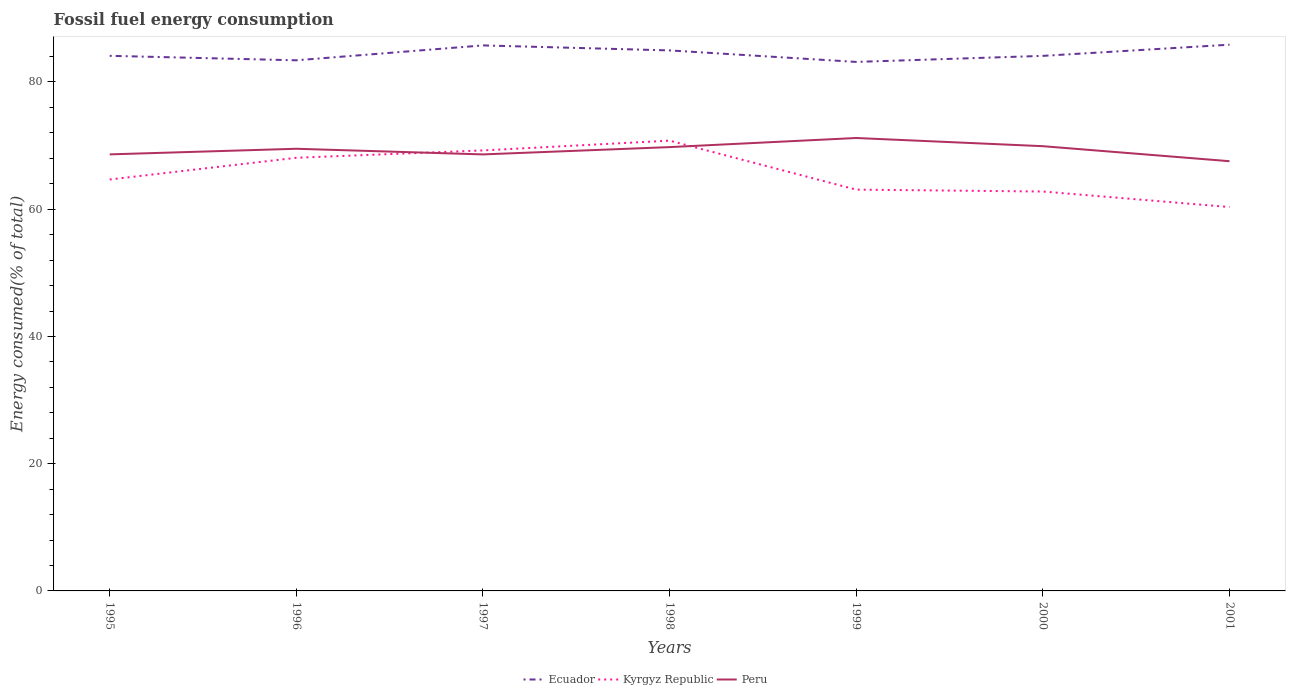How many different coloured lines are there?
Give a very brief answer. 3. Does the line corresponding to Peru intersect with the line corresponding to Kyrgyz Republic?
Your answer should be compact. Yes. Is the number of lines equal to the number of legend labels?
Offer a very short reply. Yes. Across all years, what is the maximum percentage of energy consumed in Kyrgyz Republic?
Provide a short and direct response. 60.34. In which year was the percentage of energy consumed in Ecuador maximum?
Your response must be concise. 1999. What is the total percentage of energy consumed in Kyrgyz Republic in the graph?
Provide a short and direct response. 6.16. What is the difference between the highest and the second highest percentage of energy consumed in Kyrgyz Republic?
Your response must be concise. 10.44. What is the difference between the highest and the lowest percentage of energy consumed in Ecuador?
Provide a succinct answer. 3. Is the percentage of energy consumed in Kyrgyz Republic strictly greater than the percentage of energy consumed in Peru over the years?
Your answer should be compact. No. How many years are there in the graph?
Provide a succinct answer. 7. What is the difference between two consecutive major ticks on the Y-axis?
Offer a very short reply. 20. Does the graph contain any zero values?
Keep it short and to the point. No. Where does the legend appear in the graph?
Your response must be concise. Bottom center. How many legend labels are there?
Give a very brief answer. 3. What is the title of the graph?
Offer a terse response. Fossil fuel energy consumption. Does "Nepal" appear as one of the legend labels in the graph?
Your answer should be compact. No. What is the label or title of the Y-axis?
Your response must be concise. Energy consumed(% of total). What is the Energy consumed(% of total) of Ecuador in 1995?
Your response must be concise. 84.11. What is the Energy consumed(% of total) of Kyrgyz Republic in 1995?
Offer a terse response. 64.67. What is the Energy consumed(% of total) of Peru in 1995?
Keep it short and to the point. 68.62. What is the Energy consumed(% of total) in Ecuador in 1996?
Give a very brief answer. 83.41. What is the Energy consumed(% of total) of Kyrgyz Republic in 1996?
Your answer should be compact. 68.09. What is the Energy consumed(% of total) in Peru in 1996?
Your answer should be compact. 69.5. What is the Energy consumed(% of total) in Ecuador in 1997?
Your answer should be compact. 85.75. What is the Energy consumed(% of total) in Kyrgyz Republic in 1997?
Your answer should be compact. 69.25. What is the Energy consumed(% of total) in Peru in 1997?
Provide a succinct answer. 68.62. What is the Energy consumed(% of total) of Ecuador in 1998?
Give a very brief answer. 84.97. What is the Energy consumed(% of total) in Kyrgyz Republic in 1998?
Offer a terse response. 70.78. What is the Energy consumed(% of total) of Peru in 1998?
Make the answer very short. 69.77. What is the Energy consumed(% of total) in Ecuador in 1999?
Provide a succinct answer. 83.16. What is the Energy consumed(% of total) of Kyrgyz Republic in 1999?
Keep it short and to the point. 63.08. What is the Energy consumed(% of total) in Peru in 1999?
Your response must be concise. 71.2. What is the Energy consumed(% of total) of Ecuador in 2000?
Your answer should be very brief. 84.11. What is the Energy consumed(% of total) in Kyrgyz Republic in 2000?
Provide a short and direct response. 62.78. What is the Energy consumed(% of total) in Peru in 2000?
Provide a succinct answer. 69.91. What is the Energy consumed(% of total) in Ecuador in 2001?
Make the answer very short. 85.86. What is the Energy consumed(% of total) in Kyrgyz Republic in 2001?
Your response must be concise. 60.34. What is the Energy consumed(% of total) of Peru in 2001?
Make the answer very short. 67.55. Across all years, what is the maximum Energy consumed(% of total) in Ecuador?
Ensure brevity in your answer.  85.86. Across all years, what is the maximum Energy consumed(% of total) in Kyrgyz Republic?
Ensure brevity in your answer.  70.78. Across all years, what is the maximum Energy consumed(% of total) of Peru?
Your answer should be compact. 71.2. Across all years, what is the minimum Energy consumed(% of total) in Ecuador?
Your answer should be very brief. 83.16. Across all years, what is the minimum Energy consumed(% of total) of Kyrgyz Republic?
Your answer should be compact. 60.34. Across all years, what is the minimum Energy consumed(% of total) in Peru?
Your answer should be very brief. 67.55. What is the total Energy consumed(% of total) of Ecuador in the graph?
Provide a succinct answer. 591.37. What is the total Energy consumed(% of total) in Kyrgyz Republic in the graph?
Your response must be concise. 459. What is the total Energy consumed(% of total) of Peru in the graph?
Provide a short and direct response. 485.17. What is the difference between the Energy consumed(% of total) of Ecuador in 1995 and that in 1996?
Make the answer very short. 0.7. What is the difference between the Energy consumed(% of total) of Kyrgyz Republic in 1995 and that in 1996?
Keep it short and to the point. -3.42. What is the difference between the Energy consumed(% of total) in Peru in 1995 and that in 1996?
Give a very brief answer. -0.88. What is the difference between the Energy consumed(% of total) in Ecuador in 1995 and that in 1997?
Offer a very short reply. -1.64. What is the difference between the Energy consumed(% of total) in Kyrgyz Republic in 1995 and that in 1997?
Your response must be concise. -4.57. What is the difference between the Energy consumed(% of total) of Peru in 1995 and that in 1997?
Your response must be concise. 0.01. What is the difference between the Energy consumed(% of total) of Ecuador in 1995 and that in 1998?
Make the answer very short. -0.85. What is the difference between the Energy consumed(% of total) of Kyrgyz Republic in 1995 and that in 1998?
Your response must be concise. -6.11. What is the difference between the Energy consumed(% of total) in Peru in 1995 and that in 1998?
Offer a very short reply. -1.14. What is the difference between the Energy consumed(% of total) of Ecuador in 1995 and that in 1999?
Your answer should be very brief. 0.96. What is the difference between the Energy consumed(% of total) in Kyrgyz Republic in 1995 and that in 1999?
Provide a short and direct response. 1.59. What is the difference between the Energy consumed(% of total) in Peru in 1995 and that in 1999?
Offer a very short reply. -2.57. What is the difference between the Energy consumed(% of total) of Ecuador in 1995 and that in 2000?
Give a very brief answer. 0.01. What is the difference between the Energy consumed(% of total) of Kyrgyz Republic in 1995 and that in 2000?
Keep it short and to the point. 1.89. What is the difference between the Energy consumed(% of total) of Peru in 1995 and that in 2000?
Ensure brevity in your answer.  -1.29. What is the difference between the Energy consumed(% of total) of Ecuador in 1995 and that in 2001?
Your answer should be compact. -1.75. What is the difference between the Energy consumed(% of total) in Kyrgyz Republic in 1995 and that in 2001?
Your answer should be very brief. 4.33. What is the difference between the Energy consumed(% of total) of Peru in 1995 and that in 2001?
Offer a terse response. 1.07. What is the difference between the Energy consumed(% of total) in Ecuador in 1996 and that in 1997?
Ensure brevity in your answer.  -2.34. What is the difference between the Energy consumed(% of total) in Kyrgyz Republic in 1996 and that in 1997?
Provide a succinct answer. -1.16. What is the difference between the Energy consumed(% of total) in Peru in 1996 and that in 1997?
Give a very brief answer. 0.89. What is the difference between the Energy consumed(% of total) of Ecuador in 1996 and that in 1998?
Offer a terse response. -1.55. What is the difference between the Energy consumed(% of total) of Kyrgyz Republic in 1996 and that in 1998?
Give a very brief answer. -2.69. What is the difference between the Energy consumed(% of total) in Peru in 1996 and that in 1998?
Make the answer very short. -0.26. What is the difference between the Energy consumed(% of total) in Ecuador in 1996 and that in 1999?
Give a very brief answer. 0.25. What is the difference between the Energy consumed(% of total) of Kyrgyz Republic in 1996 and that in 1999?
Provide a short and direct response. 5.01. What is the difference between the Energy consumed(% of total) in Peru in 1996 and that in 1999?
Make the answer very short. -1.69. What is the difference between the Energy consumed(% of total) in Ecuador in 1996 and that in 2000?
Your answer should be very brief. -0.7. What is the difference between the Energy consumed(% of total) of Kyrgyz Republic in 1996 and that in 2000?
Provide a short and direct response. 5.31. What is the difference between the Energy consumed(% of total) of Peru in 1996 and that in 2000?
Keep it short and to the point. -0.4. What is the difference between the Energy consumed(% of total) in Ecuador in 1996 and that in 2001?
Provide a succinct answer. -2.45. What is the difference between the Energy consumed(% of total) in Kyrgyz Republic in 1996 and that in 2001?
Make the answer very short. 7.75. What is the difference between the Energy consumed(% of total) in Peru in 1996 and that in 2001?
Provide a succinct answer. 1.96. What is the difference between the Energy consumed(% of total) of Ecuador in 1997 and that in 1998?
Keep it short and to the point. 0.79. What is the difference between the Energy consumed(% of total) of Kyrgyz Republic in 1997 and that in 1998?
Give a very brief answer. -1.53. What is the difference between the Energy consumed(% of total) in Peru in 1997 and that in 1998?
Offer a terse response. -1.15. What is the difference between the Energy consumed(% of total) of Ecuador in 1997 and that in 1999?
Offer a very short reply. 2.59. What is the difference between the Energy consumed(% of total) in Kyrgyz Republic in 1997 and that in 1999?
Keep it short and to the point. 6.17. What is the difference between the Energy consumed(% of total) in Peru in 1997 and that in 1999?
Ensure brevity in your answer.  -2.58. What is the difference between the Energy consumed(% of total) of Ecuador in 1997 and that in 2000?
Offer a very short reply. 1.64. What is the difference between the Energy consumed(% of total) of Kyrgyz Republic in 1997 and that in 2000?
Give a very brief answer. 6.46. What is the difference between the Energy consumed(% of total) in Peru in 1997 and that in 2000?
Give a very brief answer. -1.29. What is the difference between the Energy consumed(% of total) of Ecuador in 1997 and that in 2001?
Keep it short and to the point. -0.11. What is the difference between the Energy consumed(% of total) of Kyrgyz Republic in 1997 and that in 2001?
Provide a short and direct response. 8.9. What is the difference between the Energy consumed(% of total) in Peru in 1997 and that in 2001?
Provide a short and direct response. 1.07. What is the difference between the Energy consumed(% of total) of Ecuador in 1998 and that in 1999?
Provide a short and direct response. 1.81. What is the difference between the Energy consumed(% of total) of Kyrgyz Republic in 1998 and that in 1999?
Ensure brevity in your answer.  7.7. What is the difference between the Energy consumed(% of total) of Peru in 1998 and that in 1999?
Offer a very short reply. -1.43. What is the difference between the Energy consumed(% of total) of Ecuador in 1998 and that in 2000?
Your answer should be compact. 0.86. What is the difference between the Energy consumed(% of total) in Kyrgyz Republic in 1998 and that in 2000?
Make the answer very short. 8. What is the difference between the Energy consumed(% of total) in Peru in 1998 and that in 2000?
Make the answer very short. -0.14. What is the difference between the Energy consumed(% of total) of Ecuador in 1998 and that in 2001?
Provide a short and direct response. -0.9. What is the difference between the Energy consumed(% of total) of Kyrgyz Republic in 1998 and that in 2001?
Give a very brief answer. 10.44. What is the difference between the Energy consumed(% of total) in Peru in 1998 and that in 2001?
Your response must be concise. 2.22. What is the difference between the Energy consumed(% of total) of Ecuador in 1999 and that in 2000?
Offer a terse response. -0.95. What is the difference between the Energy consumed(% of total) of Kyrgyz Republic in 1999 and that in 2000?
Provide a short and direct response. 0.3. What is the difference between the Energy consumed(% of total) of Peru in 1999 and that in 2000?
Provide a succinct answer. 1.29. What is the difference between the Energy consumed(% of total) in Ecuador in 1999 and that in 2001?
Offer a very short reply. -2.71. What is the difference between the Energy consumed(% of total) in Kyrgyz Republic in 1999 and that in 2001?
Offer a terse response. 2.74. What is the difference between the Energy consumed(% of total) in Peru in 1999 and that in 2001?
Give a very brief answer. 3.65. What is the difference between the Energy consumed(% of total) of Ecuador in 2000 and that in 2001?
Provide a short and direct response. -1.76. What is the difference between the Energy consumed(% of total) in Kyrgyz Republic in 2000 and that in 2001?
Your answer should be very brief. 2.44. What is the difference between the Energy consumed(% of total) of Peru in 2000 and that in 2001?
Offer a terse response. 2.36. What is the difference between the Energy consumed(% of total) of Ecuador in 1995 and the Energy consumed(% of total) of Kyrgyz Republic in 1996?
Your response must be concise. 16.03. What is the difference between the Energy consumed(% of total) in Ecuador in 1995 and the Energy consumed(% of total) in Peru in 1996?
Provide a succinct answer. 14.61. What is the difference between the Energy consumed(% of total) in Kyrgyz Republic in 1995 and the Energy consumed(% of total) in Peru in 1996?
Make the answer very short. -4.83. What is the difference between the Energy consumed(% of total) of Ecuador in 1995 and the Energy consumed(% of total) of Kyrgyz Republic in 1997?
Your answer should be very brief. 14.87. What is the difference between the Energy consumed(% of total) of Ecuador in 1995 and the Energy consumed(% of total) of Peru in 1997?
Offer a very short reply. 15.5. What is the difference between the Energy consumed(% of total) in Kyrgyz Republic in 1995 and the Energy consumed(% of total) in Peru in 1997?
Provide a succinct answer. -3.94. What is the difference between the Energy consumed(% of total) in Ecuador in 1995 and the Energy consumed(% of total) in Kyrgyz Republic in 1998?
Offer a very short reply. 13.34. What is the difference between the Energy consumed(% of total) in Ecuador in 1995 and the Energy consumed(% of total) in Peru in 1998?
Provide a succinct answer. 14.35. What is the difference between the Energy consumed(% of total) in Kyrgyz Republic in 1995 and the Energy consumed(% of total) in Peru in 1998?
Your answer should be compact. -5.09. What is the difference between the Energy consumed(% of total) of Ecuador in 1995 and the Energy consumed(% of total) of Kyrgyz Republic in 1999?
Keep it short and to the point. 21.03. What is the difference between the Energy consumed(% of total) in Ecuador in 1995 and the Energy consumed(% of total) in Peru in 1999?
Ensure brevity in your answer.  12.92. What is the difference between the Energy consumed(% of total) in Kyrgyz Republic in 1995 and the Energy consumed(% of total) in Peru in 1999?
Give a very brief answer. -6.52. What is the difference between the Energy consumed(% of total) of Ecuador in 1995 and the Energy consumed(% of total) of Kyrgyz Republic in 2000?
Your answer should be very brief. 21.33. What is the difference between the Energy consumed(% of total) of Ecuador in 1995 and the Energy consumed(% of total) of Peru in 2000?
Keep it short and to the point. 14.21. What is the difference between the Energy consumed(% of total) of Kyrgyz Republic in 1995 and the Energy consumed(% of total) of Peru in 2000?
Your response must be concise. -5.24. What is the difference between the Energy consumed(% of total) of Ecuador in 1995 and the Energy consumed(% of total) of Kyrgyz Republic in 2001?
Your answer should be very brief. 23.77. What is the difference between the Energy consumed(% of total) in Ecuador in 1995 and the Energy consumed(% of total) in Peru in 2001?
Give a very brief answer. 16.57. What is the difference between the Energy consumed(% of total) of Kyrgyz Republic in 1995 and the Energy consumed(% of total) of Peru in 2001?
Keep it short and to the point. -2.87. What is the difference between the Energy consumed(% of total) in Ecuador in 1996 and the Energy consumed(% of total) in Kyrgyz Republic in 1997?
Give a very brief answer. 14.16. What is the difference between the Energy consumed(% of total) in Ecuador in 1996 and the Energy consumed(% of total) in Peru in 1997?
Keep it short and to the point. 14.79. What is the difference between the Energy consumed(% of total) in Kyrgyz Republic in 1996 and the Energy consumed(% of total) in Peru in 1997?
Keep it short and to the point. -0.53. What is the difference between the Energy consumed(% of total) in Ecuador in 1996 and the Energy consumed(% of total) in Kyrgyz Republic in 1998?
Your response must be concise. 12.63. What is the difference between the Energy consumed(% of total) of Ecuador in 1996 and the Energy consumed(% of total) of Peru in 1998?
Provide a short and direct response. 13.64. What is the difference between the Energy consumed(% of total) in Kyrgyz Republic in 1996 and the Energy consumed(% of total) in Peru in 1998?
Your response must be concise. -1.68. What is the difference between the Energy consumed(% of total) of Ecuador in 1996 and the Energy consumed(% of total) of Kyrgyz Republic in 1999?
Give a very brief answer. 20.33. What is the difference between the Energy consumed(% of total) in Ecuador in 1996 and the Energy consumed(% of total) in Peru in 1999?
Offer a very short reply. 12.21. What is the difference between the Energy consumed(% of total) of Kyrgyz Republic in 1996 and the Energy consumed(% of total) of Peru in 1999?
Offer a very short reply. -3.11. What is the difference between the Energy consumed(% of total) in Ecuador in 1996 and the Energy consumed(% of total) in Kyrgyz Republic in 2000?
Provide a short and direct response. 20.63. What is the difference between the Energy consumed(% of total) in Ecuador in 1996 and the Energy consumed(% of total) in Peru in 2000?
Your response must be concise. 13.5. What is the difference between the Energy consumed(% of total) in Kyrgyz Republic in 1996 and the Energy consumed(% of total) in Peru in 2000?
Offer a terse response. -1.82. What is the difference between the Energy consumed(% of total) of Ecuador in 1996 and the Energy consumed(% of total) of Kyrgyz Republic in 2001?
Make the answer very short. 23.07. What is the difference between the Energy consumed(% of total) of Ecuador in 1996 and the Energy consumed(% of total) of Peru in 2001?
Keep it short and to the point. 15.86. What is the difference between the Energy consumed(% of total) of Kyrgyz Republic in 1996 and the Energy consumed(% of total) of Peru in 2001?
Ensure brevity in your answer.  0.54. What is the difference between the Energy consumed(% of total) of Ecuador in 1997 and the Energy consumed(% of total) of Kyrgyz Republic in 1998?
Your response must be concise. 14.97. What is the difference between the Energy consumed(% of total) of Ecuador in 1997 and the Energy consumed(% of total) of Peru in 1998?
Give a very brief answer. 15.99. What is the difference between the Energy consumed(% of total) of Kyrgyz Republic in 1997 and the Energy consumed(% of total) of Peru in 1998?
Give a very brief answer. -0.52. What is the difference between the Energy consumed(% of total) of Ecuador in 1997 and the Energy consumed(% of total) of Kyrgyz Republic in 1999?
Offer a terse response. 22.67. What is the difference between the Energy consumed(% of total) in Ecuador in 1997 and the Energy consumed(% of total) in Peru in 1999?
Provide a succinct answer. 14.55. What is the difference between the Energy consumed(% of total) of Kyrgyz Republic in 1997 and the Energy consumed(% of total) of Peru in 1999?
Provide a succinct answer. -1.95. What is the difference between the Energy consumed(% of total) of Ecuador in 1997 and the Energy consumed(% of total) of Kyrgyz Republic in 2000?
Ensure brevity in your answer.  22.97. What is the difference between the Energy consumed(% of total) of Ecuador in 1997 and the Energy consumed(% of total) of Peru in 2000?
Provide a succinct answer. 15.84. What is the difference between the Energy consumed(% of total) of Kyrgyz Republic in 1997 and the Energy consumed(% of total) of Peru in 2000?
Provide a short and direct response. -0.66. What is the difference between the Energy consumed(% of total) in Ecuador in 1997 and the Energy consumed(% of total) in Kyrgyz Republic in 2001?
Provide a short and direct response. 25.41. What is the difference between the Energy consumed(% of total) in Ecuador in 1997 and the Energy consumed(% of total) in Peru in 2001?
Give a very brief answer. 18.2. What is the difference between the Energy consumed(% of total) in Kyrgyz Republic in 1997 and the Energy consumed(% of total) in Peru in 2001?
Offer a very short reply. 1.7. What is the difference between the Energy consumed(% of total) in Ecuador in 1998 and the Energy consumed(% of total) in Kyrgyz Republic in 1999?
Ensure brevity in your answer.  21.88. What is the difference between the Energy consumed(% of total) of Ecuador in 1998 and the Energy consumed(% of total) of Peru in 1999?
Provide a succinct answer. 13.77. What is the difference between the Energy consumed(% of total) in Kyrgyz Republic in 1998 and the Energy consumed(% of total) in Peru in 1999?
Provide a succinct answer. -0.42. What is the difference between the Energy consumed(% of total) of Ecuador in 1998 and the Energy consumed(% of total) of Kyrgyz Republic in 2000?
Your answer should be compact. 22.18. What is the difference between the Energy consumed(% of total) of Ecuador in 1998 and the Energy consumed(% of total) of Peru in 2000?
Offer a terse response. 15.06. What is the difference between the Energy consumed(% of total) of Kyrgyz Republic in 1998 and the Energy consumed(% of total) of Peru in 2000?
Provide a short and direct response. 0.87. What is the difference between the Energy consumed(% of total) in Ecuador in 1998 and the Energy consumed(% of total) in Kyrgyz Republic in 2001?
Ensure brevity in your answer.  24.62. What is the difference between the Energy consumed(% of total) of Ecuador in 1998 and the Energy consumed(% of total) of Peru in 2001?
Ensure brevity in your answer.  17.42. What is the difference between the Energy consumed(% of total) of Kyrgyz Republic in 1998 and the Energy consumed(% of total) of Peru in 2001?
Provide a succinct answer. 3.23. What is the difference between the Energy consumed(% of total) in Ecuador in 1999 and the Energy consumed(% of total) in Kyrgyz Republic in 2000?
Offer a terse response. 20.37. What is the difference between the Energy consumed(% of total) of Ecuador in 1999 and the Energy consumed(% of total) of Peru in 2000?
Your answer should be very brief. 13.25. What is the difference between the Energy consumed(% of total) of Kyrgyz Republic in 1999 and the Energy consumed(% of total) of Peru in 2000?
Provide a short and direct response. -6.83. What is the difference between the Energy consumed(% of total) in Ecuador in 1999 and the Energy consumed(% of total) in Kyrgyz Republic in 2001?
Your response must be concise. 22.81. What is the difference between the Energy consumed(% of total) in Ecuador in 1999 and the Energy consumed(% of total) in Peru in 2001?
Your response must be concise. 15.61. What is the difference between the Energy consumed(% of total) of Kyrgyz Republic in 1999 and the Energy consumed(% of total) of Peru in 2001?
Provide a succinct answer. -4.47. What is the difference between the Energy consumed(% of total) of Ecuador in 2000 and the Energy consumed(% of total) of Kyrgyz Republic in 2001?
Make the answer very short. 23.77. What is the difference between the Energy consumed(% of total) of Ecuador in 2000 and the Energy consumed(% of total) of Peru in 2001?
Your answer should be very brief. 16.56. What is the difference between the Energy consumed(% of total) in Kyrgyz Republic in 2000 and the Energy consumed(% of total) in Peru in 2001?
Your response must be concise. -4.77. What is the average Energy consumed(% of total) of Ecuador per year?
Ensure brevity in your answer.  84.48. What is the average Energy consumed(% of total) of Kyrgyz Republic per year?
Your response must be concise. 65.57. What is the average Energy consumed(% of total) in Peru per year?
Keep it short and to the point. 69.31. In the year 1995, what is the difference between the Energy consumed(% of total) of Ecuador and Energy consumed(% of total) of Kyrgyz Republic?
Provide a short and direct response. 19.44. In the year 1995, what is the difference between the Energy consumed(% of total) in Ecuador and Energy consumed(% of total) in Peru?
Your answer should be very brief. 15.49. In the year 1995, what is the difference between the Energy consumed(% of total) of Kyrgyz Republic and Energy consumed(% of total) of Peru?
Provide a short and direct response. -3.95. In the year 1996, what is the difference between the Energy consumed(% of total) in Ecuador and Energy consumed(% of total) in Kyrgyz Republic?
Provide a short and direct response. 15.32. In the year 1996, what is the difference between the Energy consumed(% of total) in Ecuador and Energy consumed(% of total) in Peru?
Keep it short and to the point. 13.91. In the year 1996, what is the difference between the Energy consumed(% of total) in Kyrgyz Republic and Energy consumed(% of total) in Peru?
Your response must be concise. -1.41. In the year 1997, what is the difference between the Energy consumed(% of total) in Ecuador and Energy consumed(% of total) in Kyrgyz Republic?
Provide a succinct answer. 16.51. In the year 1997, what is the difference between the Energy consumed(% of total) in Ecuador and Energy consumed(% of total) in Peru?
Your answer should be compact. 17.13. In the year 1997, what is the difference between the Energy consumed(% of total) of Kyrgyz Republic and Energy consumed(% of total) of Peru?
Your response must be concise. 0.63. In the year 1998, what is the difference between the Energy consumed(% of total) of Ecuador and Energy consumed(% of total) of Kyrgyz Republic?
Ensure brevity in your answer.  14.19. In the year 1998, what is the difference between the Energy consumed(% of total) in Ecuador and Energy consumed(% of total) in Peru?
Ensure brevity in your answer.  15.2. In the year 1998, what is the difference between the Energy consumed(% of total) in Kyrgyz Republic and Energy consumed(% of total) in Peru?
Offer a terse response. 1.01. In the year 1999, what is the difference between the Energy consumed(% of total) of Ecuador and Energy consumed(% of total) of Kyrgyz Republic?
Make the answer very short. 20.08. In the year 1999, what is the difference between the Energy consumed(% of total) in Ecuador and Energy consumed(% of total) in Peru?
Your response must be concise. 11.96. In the year 1999, what is the difference between the Energy consumed(% of total) in Kyrgyz Republic and Energy consumed(% of total) in Peru?
Provide a succinct answer. -8.12. In the year 2000, what is the difference between the Energy consumed(% of total) in Ecuador and Energy consumed(% of total) in Kyrgyz Republic?
Offer a very short reply. 21.32. In the year 2000, what is the difference between the Energy consumed(% of total) of Ecuador and Energy consumed(% of total) of Peru?
Keep it short and to the point. 14.2. In the year 2000, what is the difference between the Energy consumed(% of total) of Kyrgyz Republic and Energy consumed(% of total) of Peru?
Provide a short and direct response. -7.13. In the year 2001, what is the difference between the Energy consumed(% of total) in Ecuador and Energy consumed(% of total) in Kyrgyz Republic?
Offer a very short reply. 25.52. In the year 2001, what is the difference between the Energy consumed(% of total) of Ecuador and Energy consumed(% of total) of Peru?
Your response must be concise. 18.31. In the year 2001, what is the difference between the Energy consumed(% of total) of Kyrgyz Republic and Energy consumed(% of total) of Peru?
Ensure brevity in your answer.  -7.21. What is the ratio of the Energy consumed(% of total) of Ecuador in 1995 to that in 1996?
Give a very brief answer. 1.01. What is the ratio of the Energy consumed(% of total) in Kyrgyz Republic in 1995 to that in 1996?
Your answer should be very brief. 0.95. What is the ratio of the Energy consumed(% of total) in Peru in 1995 to that in 1996?
Provide a short and direct response. 0.99. What is the ratio of the Energy consumed(% of total) in Ecuador in 1995 to that in 1997?
Your answer should be compact. 0.98. What is the ratio of the Energy consumed(% of total) in Kyrgyz Republic in 1995 to that in 1997?
Provide a short and direct response. 0.93. What is the ratio of the Energy consumed(% of total) in Ecuador in 1995 to that in 1998?
Keep it short and to the point. 0.99. What is the ratio of the Energy consumed(% of total) of Kyrgyz Republic in 1995 to that in 1998?
Provide a short and direct response. 0.91. What is the ratio of the Energy consumed(% of total) in Peru in 1995 to that in 1998?
Provide a succinct answer. 0.98. What is the ratio of the Energy consumed(% of total) of Ecuador in 1995 to that in 1999?
Offer a very short reply. 1.01. What is the ratio of the Energy consumed(% of total) of Kyrgyz Republic in 1995 to that in 1999?
Your response must be concise. 1.03. What is the ratio of the Energy consumed(% of total) in Peru in 1995 to that in 1999?
Give a very brief answer. 0.96. What is the ratio of the Energy consumed(% of total) in Ecuador in 1995 to that in 2000?
Provide a short and direct response. 1. What is the ratio of the Energy consumed(% of total) of Kyrgyz Republic in 1995 to that in 2000?
Offer a terse response. 1.03. What is the ratio of the Energy consumed(% of total) in Peru in 1995 to that in 2000?
Provide a succinct answer. 0.98. What is the ratio of the Energy consumed(% of total) of Ecuador in 1995 to that in 2001?
Give a very brief answer. 0.98. What is the ratio of the Energy consumed(% of total) in Kyrgyz Republic in 1995 to that in 2001?
Offer a terse response. 1.07. What is the ratio of the Energy consumed(% of total) in Peru in 1995 to that in 2001?
Provide a short and direct response. 1.02. What is the ratio of the Energy consumed(% of total) in Ecuador in 1996 to that in 1997?
Offer a very short reply. 0.97. What is the ratio of the Energy consumed(% of total) of Kyrgyz Republic in 1996 to that in 1997?
Keep it short and to the point. 0.98. What is the ratio of the Energy consumed(% of total) of Peru in 1996 to that in 1997?
Ensure brevity in your answer.  1.01. What is the ratio of the Energy consumed(% of total) of Ecuador in 1996 to that in 1998?
Your answer should be compact. 0.98. What is the ratio of the Energy consumed(% of total) in Kyrgyz Republic in 1996 to that in 1998?
Make the answer very short. 0.96. What is the ratio of the Energy consumed(% of total) in Peru in 1996 to that in 1998?
Offer a terse response. 1. What is the ratio of the Energy consumed(% of total) in Kyrgyz Republic in 1996 to that in 1999?
Ensure brevity in your answer.  1.08. What is the ratio of the Energy consumed(% of total) of Peru in 1996 to that in 1999?
Your answer should be very brief. 0.98. What is the ratio of the Energy consumed(% of total) in Ecuador in 1996 to that in 2000?
Your response must be concise. 0.99. What is the ratio of the Energy consumed(% of total) in Kyrgyz Republic in 1996 to that in 2000?
Ensure brevity in your answer.  1.08. What is the ratio of the Energy consumed(% of total) in Peru in 1996 to that in 2000?
Provide a succinct answer. 0.99. What is the ratio of the Energy consumed(% of total) in Ecuador in 1996 to that in 2001?
Your answer should be compact. 0.97. What is the ratio of the Energy consumed(% of total) of Kyrgyz Republic in 1996 to that in 2001?
Keep it short and to the point. 1.13. What is the ratio of the Energy consumed(% of total) of Peru in 1996 to that in 2001?
Offer a very short reply. 1.03. What is the ratio of the Energy consumed(% of total) of Ecuador in 1997 to that in 1998?
Your answer should be compact. 1.01. What is the ratio of the Energy consumed(% of total) of Kyrgyz Republic in 1997 to that in 1998?
Your response must be concise. 0.98. What is the ratio of the Energy consumed(% of total) in Peru in 1997 to that in 1998?
Your answer should be very brief. 0.98. What is the ratio of the Energy consumed(% of total) of Ecuador in 1997 to that in 1999?
Your answer should be compact. 1.03. What is the ratio of the Energy consumed(% of total) in Kyrgyz Republic in 1997 to that in 1999?
Your answer should be compact. 1.1. What is the ratio of the Energy consumed(% of total) of Peru in 1997 to that in 1999?
Provide a short and direct response. 0.96. What is the ratio of the Energy consumed(% of total) in Ecuador in 1997 to that in 2000?
Offer a very short reply. 1.02. What is the ratio of the Energy consumed(% of total) in Kyrgyz Republic in 1997 to that in 2000?
Keep it short and to the point. 1.1. What is the ratio of the Energy consumed(% of total) of Peru in 1997 to that in 2000?
Ensure brevity in your answer.  0.98. What is the ratio of the Energy consumed(% of total) of Kyrgyz Republic in 1997 to that in 2001?
Ensure brevity in your answer.  1.15. What is the ratio of the Energy consumed(% of total) in Peru in 1997 to that in 2001?
Keep it short and to the point. 1.02. What is the ratio of the Energy consumed(% of total) in Ecuador in 1998 to that in 1999?
Keep it short and to the point. 1.02. What is the ratio of the Energy consumed(% of total) in Kyrgyz Republic in 1998 to that in 1999?
Your answer should be compact. 1.12. What is the ratio of the Energy consumed(% of total) in Peru in 1998 to that in 1999?
Offer a very short reply. 0.98. What is the ratio of the Energy consumed(% of total) in Ecuador in 1998 to that in 2000?
Your response must be concise. 1.01. What is the ratio of the Energy consumed(% of total) in Kyrgyz Republic in 1998 to that in 2000?
Make the answer very short. 1.13. What is the ratio of the Energy consumed(% of total) in Peru in 1998 to that in 2000?
Your response must be concise. 1. What is the ratio of the Energy consumed(% of total) of Ecuador in 1998 to that in 2001?
Your answer should be very brief. 0.99. What is the ratio of the Energy consumed(% of total) in Kyrgyz Republic in 1998 to that in 2001?
Give a very brief answer. 1.17. What is the ratio of the Energy consumed(% of total) of Peru in 1998 to that in 2001?
Your answer should be compact. 1.03. What is the ratio of the Energy consumed(% of total) in Ecuador in 1999 to that in 2000?
Keep it short and to the point. 0.99. What is the ratio of the Energy consumed(% of total) of Peru in 1999 to that in 2000?
Give a very brief answer. 1.02. What is the ratio of the Energy consumed(% of total) of Ecuador in 1999 to that in 2001?
Your answer should be very brief. 0.97. What is the ratio of the Energy consumed(% of total) in Kyrgyz Republic in 1999 to that in 2001?
Offer a very short reply. 1.05. What is the ratio of the Energy consumed(% of total) of Peru in 1999 to that in 2001?
Offer a terse response. 1.05. What is the ratio of the Energy consumed(% of total) of Ecuador in 2000 to that in 2001?
Provide a succinct answer. 0.98. What is the ratio of the Energy consumed(% of total) of Kyrgyz Republic in 2000 to that in 2001?
Offer a very short reply. 1.04. What is the ratio of the Energy consumed(% of total) of Peru in 2000 to that in 2001?
Your answer should be very brief. 1.03. What is the difference between the highest and the second highest Energy consumed(% of total) in Ecuador?
Offer a very short reply. 0.11. What is the difference between the highest and the second highest Energy consumed(% of total) of Kyrgyz Republic?
Give a very brief answer. 1.53. What is the difference between the highest and the second highest Energy consumed(% of total) of Peru?
Make the answer very short. 1.29. What is the difference between the highest and the lowest Energy consumed(% of total) in Ecuador?
Keep it short and to the point. 2.71. What is the difference between the highest and the lowest Energy consumed(% of total) in Kyrgyz Republic?
Make the answer very short. 10.44. What is the difference between the highest and the lowest Energy consumed(% of total) in Peru?
Offer a terse response. 3.65. 